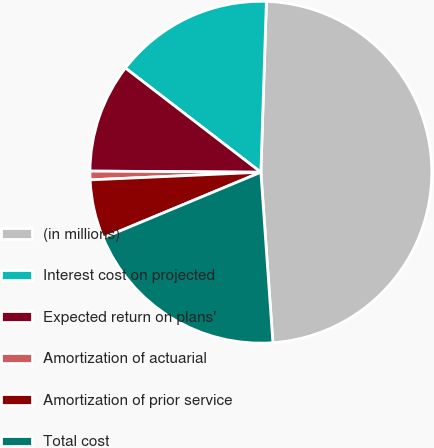Convert chart to OTSL. <chart><loc_0><loc_0><loc_500><loc_500><pie_chart><fcel>(in millions)<fcel>Interest cost on projected<fcel>Expected return on plans'<fcel>Amortization of actuarial<fcel>Amortization of prior service<fcel>Total cost<nl><fcel>48.37%<fcel>15.08%<fcel>10.33%<fcel>0.82%<fcel>5.57%<fcel>19.84%<nl></chart> 